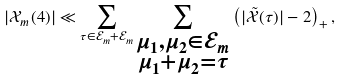Convert formula to latex. <formula><loc_0><loc_0><loc_500><loc_500>| \mathcal { X } _ { m } ( 4 ) | \ll \sum _ { \tau \in \mathcal { E } _ { m } + \mathcal { E } _ { m } } \sum _ { \substack { \mu _ { 1 } , \mu _ { 2 } \in \mathcal { E } _ { m } \\ \mu _ { 1 } + \mu _ { 2 } = \tau } } \left ( | \tilde { \mathcal { X } } ( \tau ) | - 2 \right ) _ { + } ,</formula> 